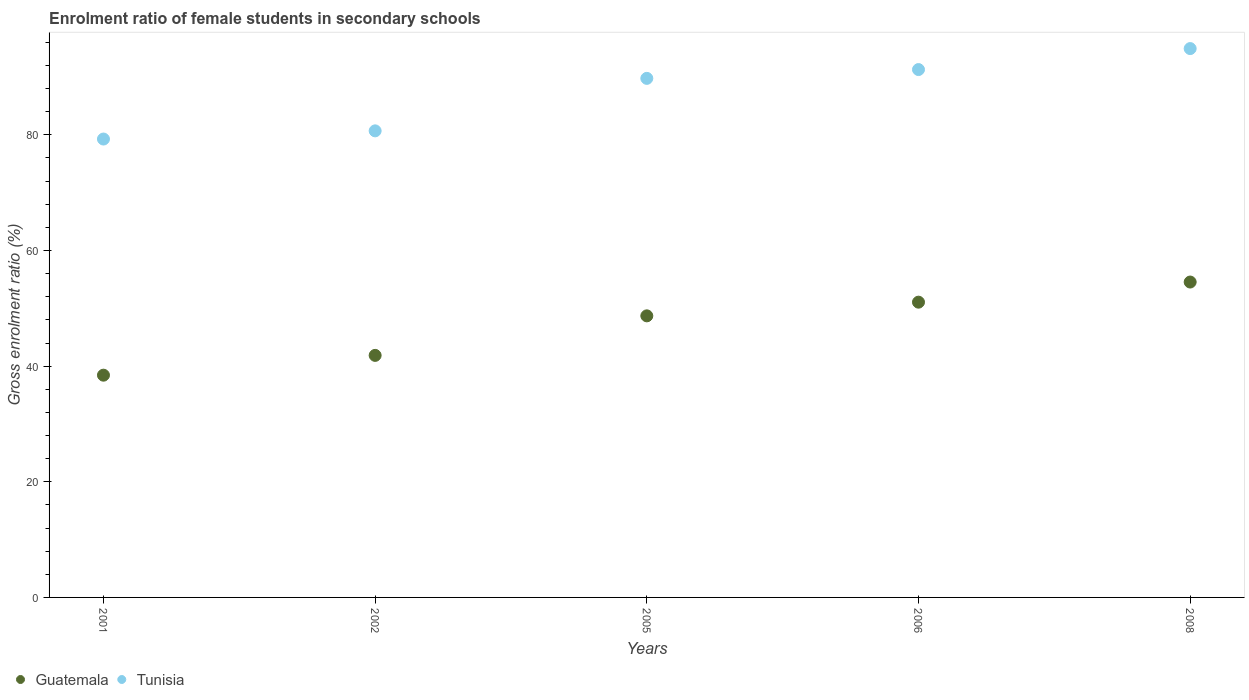What is the enrolment ratio of female students in secondary schools in Tunisia in 2005?
Keep it short and to the point. 89.77. Across all years, what is the maximum enrolment ratio of female students in secondary schools in Guatemala?
Make the answer very short. 54.55. Across all years, what is the minimum enrolment ratio of female students in secondary schools in Tunisia?
Offer a terse response. 79.28. In which year was the enrolment ratio of female students in secondary schools in Tunisia minimum?
Give a very brief answer. 2001. What is the total enrolment ratio of female students in secondary schools in Guatemala in the graph?
Offer a terse response. 234.61. What is the difference between the enrolment ratio of female students in secondary schools in Guatemala in 2002 and that in 2005?
Ensure brevity in your answer.  -6.84. What is the difference between the enrolment ratio of female students in secondary schools in Guatemala in 2006 and the enrolment ratio of female students in secondary schools in Tunisia in 2001?
Your answer should be compact. -28.21. What is the average enrolment ratio of female students in secondary schools in Guatemala per year?
Provide a short and direct response. 46.92. In the year 2002, what is the difference between the enrolment ratio of female students in secondary schools in Tunisia and enrolment ratio of female students in secondary schools in Guatemala?
Give a very brief answer. 38.83. In how many years, is the enrolment ratio of female students in secondary schools in Guatemala greater than 12 %?
Your answer should be very brief. 5. What is the ratio of the enrolment ratio of female students in secondary schools in Tunisia in 2002 to that in 2006?
Keep it short and to the point. 0.88. Is the difference between the enrolment ratio of female students in secondary schools in Tunisia in 2001 and 2005 greater than the difference between the enrolment ratio of female students in secondary schools in Guatemala in 2001 and 2005?
Provide a short and direct response. No. What is the difference between the highest and the second highest enrolment ratio of female students in secondary schools in Tunisia?
Ensure brevity in your answer.  3.63. What is the difference between the highest and the lowest enrolment ratio of female students in secondary schools in Tunisia?
Give a very brief answer. 15.65. In how many years, is the enrolment ratio of female students in secondary schools in Tunisia greater than the average enrolment ratio of female students in secondary schools in Tunisia taken over all years?
Your answer should be very brief. 3. Is the sum of the enrolment ratio of female students in secondary schools in Tunisia in 2006 and 2008 greater than the maximum enrolment ratio of female students in secondary schools in Guatemala across all years?
Offer a very short reply. Yes. Does the enrolment ratio of female students in secondary schools in Tunisia monotonically increase over the years?
Give a very brief answer. Yes. Is the enrolment ratio of female students in secondary schools in Tunisia strictly greater than the enrolment ratio of female students in secondary schools in Guatemala over the years?
Ensure brevity in your answer.  Yes. Is the enrolment ratio of female students in secondary schools in Guatemala strictly less than the enrolment ratio of female students in secondary schools in Tunisia over the years?
Provide a short and direct response. Yes. Where does the legend appear in the graph?
Your answer should be very brief. Bottom left. How are the legend labels stacked?
Your response must be concise. Horizontal. What is the title of the graph?
Give a very brief answer. Enrolment ratio of female students in secondary schools. Does "Liechtenstein" appear as one of the legend labels in the graph?
Your answer should be compact. No. What is the label or title of the X-axis?
Keep it short and to the point. Years. What is the Gross enrolment ratio (%) in Guatemala in 2001?
Offer a very short reply. 38.44. What is the Gross enrolment ratio (%) of Tunisia in 2001?
Offer a terse response. 79.28. What is the Gross enrolment ratio (%) in Guatemala in 2002?
Offer a very short reply. 41.86. What is the Gross enrolment ratio (%) in Tunisia in 2002?
Make the answer very short. 80.69. What is the Gross enrolment ratio (%) in Guatemala in 2005?
Provide a short and direct response. 48.7. What is the Gross enrolment ratio (%) in Tunisia in 2005?
Offer a terse response. 89.77. What is the Gross enrolment ratio (%) in Guatemala in 2006?
Provide a short and direct response. 51.06. What is the Gross enrolment ratio (%) in Tunisia in 2006?
Provide a succinct answer. 91.29. What is the Gross enrolment ratio (%) of Guatemala in 2008?
Your answer should be very brief. 54.55. What is the Gross enrolment ratio (%) of Tunisia in 2008?
Your response must be concise. 94.92. Across all years, what is the maximum Gross enrolment ratio (%) of Guatemala?
Make the answer very short. 54.55. Across all years, what is the maximum Gross enrolment ratio (%) in Tunisia?
Provide a succinct answer. 94.92. Across all years, what is the minimum Gross enrolment ratio (%) of Guatemala?
Make the answer very short. 38.44. Across all years, what is the minimum Gross enrolment ratio (%) of Tunisia?
Keep it short and to the point. 79.28. What is the total Gross enrolment ratio (%) in Guatemala in the graph?
Provide a short and direct response. 234.61. What is the total Gross enrolment ratio (%) in Tunisia in the graph?
Give a very brief answer. 435.96. What is the difference between the Gross enrolment ratio (%) in Guatemala in 2001 and that in 2002?
Ensure brevity in your answer.  -3.42. What is the difference between the Gross enrolment ratio (%) of Tunisia in 2001 and that in 2002?
Ensure brevity in your answer.  -1.42. What is the difference between the Gross enrolment ratio (%) in Guatemala in 2001 and that in 2005?
Give a very brief answer. -10.26. What is the difference between the Gross enrolment ratio (%) in Tunisia in 2001 and that in 2005?
Keep it short and to the point. -10.49. What is the difference between the Gross enrolment ratio (%) of Guatemala in 2001 and that in 2006?
Offer a very short reply. -12.63. What is the difference between the Gross enrolment ratio (%) of Tunisia in 2001 and that in 2006?
Your answer should be compact. -12.02. What is the difference between the Gross enrolment ratio (%) of Guatemala in 2001 and that in 2008?
Offer a terse response. -16.11. What is the difference between the Gross enrolment ratio (%) of Tunisia in 2001 and that in 2008?
Provide a short and direct response. -15.65. What is the difference between the Gross enrolment ratio (%) in Guatemala in 2002 and that in 2005?
Offer a very short reply. -6.84. What is the difference between the Gross enrolment ratio (%) of Tunisia in 2002 and that in 2005?
Make the answer very short. -9.08. What is the difference between the Gross enrolment ratio (%) of Guatemala in 2002 and that in 2006?
Offer a very short reply. -9.2. What is the difference between the Gross enrolment ratio (%) of Tunisia in 2002 and that in 2006?
Keep it short and to the point. -10.6. What is the difference between the Gross enrolment ratio (%) of Guatemala in 2002 and that in 2008?
Make the answer very short. -12.69. What is the difference between the Gross enrolment ratio (%) in Tunisia in 2002 and that in 2008?
Your answer should be very brief. -14.23. What is the difference between the Gross enrolment ratio (%) in Guatemala in 2005 and that in 2006?
Your answer should be compact. -2.37. What is the difference between the Gross enrolment ratio (%) in Tunisia in 2005 and that in 2006?
Provide a short and direct response. -1.52. What is the difference between the Gross enrolment ratio (%) in Guatemala in 2005 and that in 2008?
Provide a succinct answer. -5.85. What is the difference between the Gross enrolment ratio (%) of Tunisia in 2005 and that in 2008?
Offer a very short reply. -5.15. What is the difference between the Gross enrolment ratio (%) in Guatemala in 2006 and that in 2008?
Your answer should be very brief. -3.48. What is the difference between the Gross enrolment ratio (%) of Tunisia in 2006 and that in 2008?
Give a very brief answer. -3.63. What is the difference between the Gross enrolment ratio (%) in Guatemala in 2001 and the Gross enrolment ratio (%) in Tunisia in 2002?
Provide a succinct answer. -42.26. What is the difference between the Gross enrolment ratio (%) of Guatemala in 2001 and the Gross enrolment ratio (%) of Tunisia in 2005?
Offer a very short reply. -51.33. What is the difference between the Gross enrolment ratio (%) of Guatemala in 2001 and the Gross enrolment ratio (%) of Tunisia in 2006?
Ensure brevity in your answer.  -52.86. What is the difference between the Gross enrolment ratio (%) in Guatemala in 2001 and the Gross enrolment ratio (%) in Tunisia in 2008?
Give a very brief answer. -56.48. What is the difference between the Gross enrolment ratio (%) in Guatemala in 2002 and the Gross enrolment ratio (%) in Tunisia in 2005?
Provide a short and direct response. -47.91. What is the difference between the Gross enrolment ratio (%) of Guatemala in 2002 and the Gross enrolment ratio (%) of Tunisia in 2006?
Your response must be concise. -49.43. What is the difference between the Gross enrolment ratio (%) in Guatemala in 2002 and the Gross enrolment ratio (%) in Tunisia in 2008?
Provide a succinct answer. -53.06. What is the difference between the Gross enrolment ratio (%) of Guatemala in 2005 and the Gross enrolment ratio (%) of Tunisia in 2006?
Make the answer very short. -42.59. What is the difference between the Gross enrolment ratio (%) of Guatemala in 2005 and the Gross enrolment ratio (%) of Tunisia in 2008?
Offer a very short reply. -46.22. What is the difference between the Gross enrolment ratio (%) of Guatemala in 2006 and the Gross enrolment ratio (%) of Tunisia in 2008?
Provide a succinct answer. -43.86. What is the average Gross enrolment ratio (%) of Guatemala per year?
Offer a very short reply. 46.92. What is the average Gross enrolment ratio (%) of Tunisia per year?
Offer a terse response. 87.19. In the year 2001, what is the difference between the Gross enrolment ratio (%) of Guatemala and Gross enrolment ratio (%) of Tunisia?
Your answer should be very brief. -40.84. In the year 2002, what is the difference between the Gross enrolment ratio (%) in Guatemala and Gross enrolment ratio (%) in Tunisia?
Offer a very short reply. -38.83. In the year 2005, what is the difference between the Gross enrolment ratio (%) of Guatemala and Gross enrolment ratio (%) of Tunisia?
Ensure brevity in your answer.  -41.07. In the year 2006, what is the difference between the Gross enrolment ratio (%) in Guatemala and Gross enrolment ratio (%) in Tunisia?
Give a very brief answer. -40.23. In the year 2008, what is the difference between the Gross enrolment ratio (%) of Guatemala and Gross enrolment ratio (%) of Tunisia?
Provide a short and direct response. -40.38. What is the ratio of the Gross enrolment ratio (%) in Guatemala in 2001 to that in 2002?
Keep it short and to the point. 0.92. What is the ratio of the Gross enrolment ratio (%) in Tunisia in 2001 to that in 2002?
Keep it short and to the point. 0.98. What is the ratio of the Gross enrolment ratio (%) of Guatemala in 2001 to that in 2005?
Offer a terse response. 0.79. What is the ratio of the Gross enrolment ratio (%) in Tunisia in 2001 to that in 2005?
Your response must be concise. 0.88. What is the ratio of the Gross enrolment ratio (%) of Guatemala in 2001 to that in 2006?
Provide a short and direct response. 0.75. What is the ratio of the Gross enrolment ratio (%) in Tunisia in 2001 to that in 2006?
Make the answer very short. 0.87. What is the ratio of the Gross enrolment ratio (%) in Guatemala in 2001 to that in 2008?
Make the answer very short. 0.7. What is the ratio of the Gross enrolment ratio (%) of Tunisia in 2001 to that in 2008?
Give a very brief answer. 0.84. What is the ratio of the Gross enrolment ratio (%) of Guatemala in 2002 to that in 2005?
Provide a short and direct response. 0.86. What is the ratio of the Gross enrolment ratio (%) of Tunisia in 2002 to that in 2005?
Your response must be concise. 0.9. What is the ratio of the Gross enrolment ratio (%) in Guatemala in 2002 to that in 2006?
Your answer should be very brief. 0.82. What is the ratio of the Gross enrolment ratio (%) of Tunisia in 2002 to that in 2006?
Your response must be concise. 0.88. What is the ratio of the Gross enrolment ratio (%) in Guatemala in 2002 to that in 2008?
Ensure brevity in your answer.  0.77. What is the ratio of the Gross enrolment ratio (%) in Tunisia in 2002 to that in 2008?
Ensure brevity in your answer.  0.85. What is the ratio of the Gross enrolment ratio (%) of Guatemala in 2005 to that in 2006?
Give a very brief answer. 0.95. What is the ratio of the Gross enrolment ratio (%) of Tunisia in 2005 to that in 2006?
Your response must be concise. 0.98. What is the ratio of the Gross enrolment ratio (%) in Guatemala in 2005 to that in 2008?
Ensure brevity in your answer.  0.89. What is the ratio of the Gross enrolment ratio (%) of Tunisia in 2005 to that in 2008?
Your response must be concise. 0.95. What is the ratio of the Gross enrolment ratio (%) of Guatemala in 2006 to that in 2008?
Your answer should be very brief. 0.94. What is the ratio of the Gross enrolment ratio (%) in Tunisia in 2006 to that in 2008?
Make the answer very short. 0.96. What is the difference between the highest and the second highest Gross enrolment ratio (%) of Guatemala?
Keep it short and to the point. 3.48. What is the difference between the highest and the second highest Gross enrolment ratio (%) in Tunisia?
Your answer should be very brief. 3.63. What is the difference between the highest and the lowest Gross enrolment ratio (%) in Guatemala?
Make the answer very short. 16.11. What is the difference between the highest and the lowest Gross enrolment ratio (%) of Tunisia?
Make the answer very short. 15.65. 